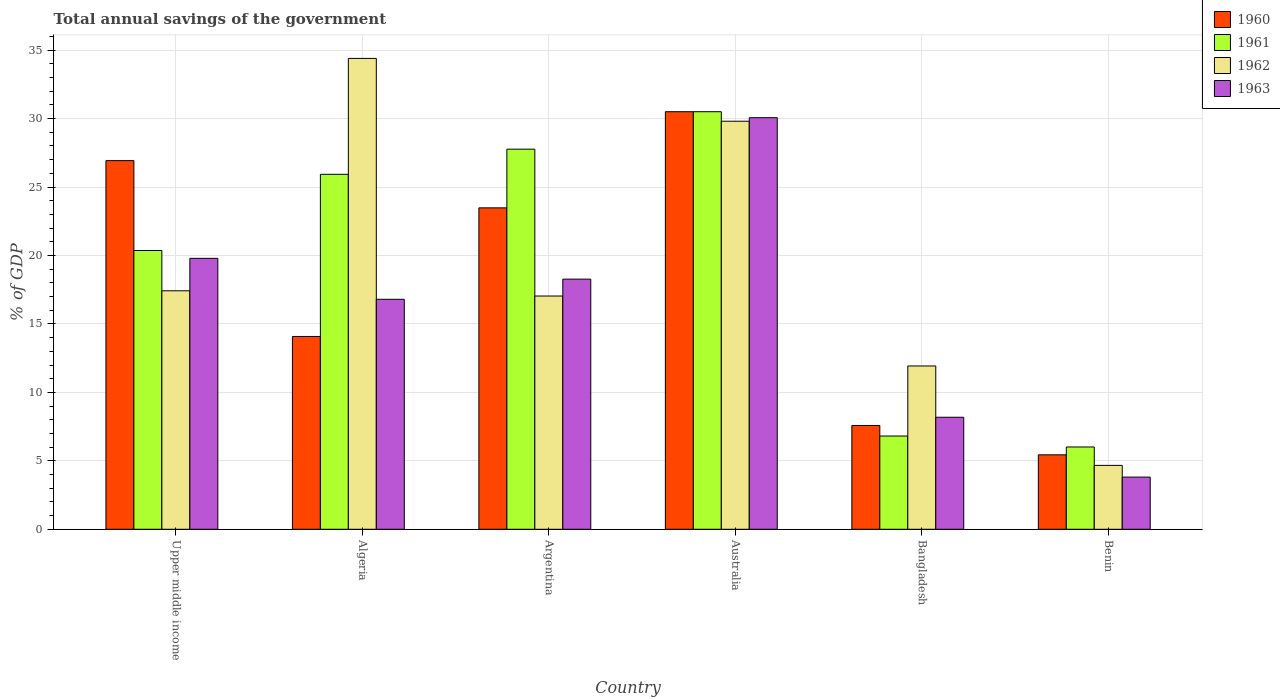How many different coloured bars are there?
Your answer should be compact. 4. Are the number of bars per tick equal to the number of legend labels?
Your answer should be compact. Yes. How many bars are there on the 4th tick from the left?
Give a very brief answer. 4. How many bars are there on the 3rd tick from the right?
Provide a succinct answer. 4. What is the label of the 1st group of bars from the left?
Offer a very short reply. Upper middle income. In how many cases, is the number of bars for a given country not equal to the number of legend labels?
Your response must be concise. 0. What is the total annual savings of the government in 1962 in Upper middle income?
Provide a short and direct response. 17.42. Across all countries, what is the maximum total annual savings of the government in 1960?
Offer a very short reply. 30.5. Across all countries, what is the minimum total annual savings of the government in 1961?
Your answer should be very brief. 6.01. In which country was the total annual savings of the government in 1963 maximum?
Provide a short and direct response. Australia. In which country was the total annual savings of the government in 1962 minimum?
Provide a succinct answer. Benin. What is the total total annual savings of the government in 1963 in the graph?
Provide a succinct answer. 96.92. What is the difference between the total annual savings of the government in 1961 in Argentina and that in Benin?
Offer a terse response. 21.75. What is the difference between the total annual savings of the government in 1961 in Benin and the total annual savings of the government in 1960 in Bangladesh?
Offer a terse response. -1.57. What is the average total annual savings of the government in 1961 per country?
Your response must be concise. 19.56. What is the difference between the total annual savings of the government of/in 1963 and total annual savings of the government of/in 1962 in Benin?
Offer a terse response. -0.86. In how many countries, is the total annual savings of the government in 1963 greater than 9 %?
Make the answer very short. 4. What is the ratio of the total annual savings of the government in 1963 in Benin to that in Upper middle income?
Your answer should be compact. 0.19. Is the total annual savings of the government in 1963 in Argentina less than that in Australia?
Give a very brief answer. Yes. Is the difference between the total annual savings of the government in 1963 in Algeria and Argentina greater than the difference between the total annual savings of the government in 1962 in Algeria and Argentina?
Offer a terse response. No. What is the difference between the highest and the second highest total annual savings of the government in 1960?
Your answer should be compact. -3.57. What is the difference between the highest and the lowest total annual savings of the government in 1963?
Ensure brevity in your answer.  26.25. Is it the case that in every country, the sum of the total annual savings of the government in 1961 and total annual savings of the government in 1960 is greater than the sum of total annual savings of the government in 1963 and total annual savings of the government in 1962?
Provide a short and direct response. No. What does the 4th bar from the right in Argentina represents?
Your answer should be very brief. 1960. How many bars are there?
Your answer should be compact. 24. Are all the bars in the graph horizontal?
Provide a short and direct response. No. How many countries are there in the graph?
Keep it short and to the point. 6. What is the difference between two consecutive major ticks on the Y-axis?
Your response must be concise. 5. How many legend labels are there?
Your answer should be very brief. 4. What is the title of the graph?
Your answer should be compact. Total annual savings of the government. Does "2004" appear as one of the legend labels in the graph?
Your answer should be compact. No. What is the label or title of the Y-axis?
Offer a terse response. % of GDP. What is the % of GDP of 1960 in Upper middle income?
Offer a very short reply. 26.93. What is the % of GDP in 1961 in Upper middle income?
Offer a very short reply. 20.37. What is the % of GDP in 1962 in Upper middle income?
Provide a succinct answer. 17.42. What is the % of GDP in 1963 in Upper middle income?
Your answer should be compact. 19.79. What is the % of GDP in 1960 in Algeria?
Keep it short and to the point. 14.08. What is the % of GDP of 1961 in Algeria?
Your answer should be compact. 25.93. What is the % of GDP of 1962 in Algeria?
Offer a very short reply. 34.4. What is the % of GDP of 1963 in Algeria?
Your response must be concise. 16.8. What is the % of GDP of 1960 in Argentina?
Provide a short and direct response. 23.48. What is the % of GDP of 1961 in Argentina?
Your response must be concise. 27.77. What is the % of GDP in 1962 in Argentina?
Offer a very short reply. 17.04. What is the % of GDP in 1963 in Argentina?
Provide a succinct answer. 18.27. What is the % of GDP of 1960 in Australia?
Offer a very short reply. 30.5. What is the % of GDP of 1961 in Australia?
Your answer should be very brief. 30.5. What is the % of GDP of 1962 in Australia?
Keep it short and to the point. 29.81. What is the % of GDP of 1963 in Australia?
Ensure brevity in your answer.  30.07. What is the % of GDP of 1960 in Bangladesh?
Keep it short and to the point. 7.58. What is the % of GDP of 1961 in Bangladesh?
Make the answer very short. 6.81. What is the % of GDP of 1962 in Bangladesh?
Give a very brief answer. 11.93. What is the % of GDP in 1963 in Bangladesh?
Offer a very short reply. 8.18. What is the % of GDP of 1960 in Benin?
Offer a terse response. 5.44. What is the % of GDP of 1961 in Benin?
Offer a terse response. 6.01. What is the % of GDP of 1962 in Benin?
Offer a terse response. 4.67. What is the % of GDP in 1963 in Benin?
Provide a short and direct response. 3.81. Across all countries, what is the maximum % of GDP in 1960?
Offer a terse response. 30.5. Across all countries, what is the maximum % of GDP of 1961?
Offer a very short reply. 30.5. Across all countries, what is the maximum % of GDP in 1962?
Make the answer very short. 34.4. Across all countries, what is the maximum % of GDP in 1963?
Your answer should be compact. 30.07. Across all countries, what is the minimum % of GDP in 1960?
Provide a short and direct response. 5.44. Across all countries, what is the minimum % of GDP of 1961?
Provide a succinct answer. 6.01. Across all countries, what is the minimum % of GDP in 1962?
Make the answer very short. 4.67. Across all countries, what is the minimum % of GDP of 1963?
Make the answer very short. 3.81. What is the total % of GDP of 1960 in the graph?
Make the answer very short. 108.02. What is the total % of GDP of 1961 in the graph?
Ensure brevity in your answer.  117.39. What is the total % of GDP of 1962 in the graph?
Your response must be concise. 115.26. What is the total % of GDP in 1963 in the graph?
Keep it short and to the point. 96.92. What is the difference between the % of GDP in 1960 in Upper middle income and that in Algeria?
Offer a terse response. 12.84. What is the difference between the % of GDP of 1961 in Upper middle income and that in Algeria?
Give a very brief answer. -5.57. What is the difference between the % of GDP in 1962 in Upper middle income and that in Algeria?
Your answer should be very brief. -16.97. What is the difference between the % of GDP of 1963 in Upper middle income and that in Algeria?
Your answer should be very brief. 2.99. What is the difference between the % of GDP of 1960 in Upper middle income and that in Argentina?
Provide a short and direct response. 3.45. What is the difference between the % of GDP of 1961 in Upper middle income and that in Argentina?
Provide a short and direct response. -7.4. What is the difference between the % of GDP of 1962 in Upper middle income and that in Argentina?
Offer a terse response. 0.38. What is the difference between the % of GDP of 1963 in Upper middle income and that in Argentina?
Your response must be concise. 1.52. What is the difference between the % of GDP in 1960 in Upper middle income and that in Australia?
Provide a succinct answer. -3.57. What is the difference between the % of GDP of 1961 in Upper middle income and that in Australia?
Keep it short and to the point. -10.14. What is the difference between the % of GDP of 1962 in Upper middle income and that in Australia?
Give a very brief answer. -12.39. What is the difference between the % of GDP in 1963 in Upper middle income and that in Australia?
Offer a very short reply. -10.27. What is the difference between the % of GDP of 1960 in Upper middle income and that in Bangladesh?
Make the answer very short. 19.35. What is the difference between the % of GDP of 1961 in Upper middle income and that in Bangladesh?
Your answer should be compact. 13.55. What is the difference between the % of GDP in 1962 in Upper middle income and that in Bangladesh?
Give a very brief answer. 5.49. What is the difference between the % of GDP of 1963 in Upper middle income and that in Bangladesh?
Provide a succinct answer. 11.61. What is the difference between the % of GDP of 1960 in Upper middle income and that in Benin?
Your answer should be very brief. 21.49. What is the difference between the % of GDP in 1961 in Upper middle income and that in Benin?
Offer a very short reply. 14.35. What is the difference between the % of GDP in 1962 in Upper middle income and that in Benin?
Your response must be concise. 12.75. What is the difference between the % of GDP in 1963 in Upper middle income and that in Benin?
Provide a short and direct response. 15.98. What is the difference between the % of GDP of 1960 in Algeria and that in Argentina?
Your response must be concise. -9.4. What is the difference between the % of GDP of 1961 in Algeria and that in Argentina?
Make the answer very short. -1.84. What is the difference between the % of GDP of 1962 in Algeria and that in Argentina?
Your response must be concise. 17.36. What is the difference between the % of GDP of 1963 in Algeria and that in Argentina?
Offer a terse response. -1.47. What is the difference between the % of GDP in 1960 in Algeria and that in Australia?
Your answer should be very brief. -16.42. What is the difference between the % of GDP of 1961 in Algeria and that in Australia?
Your answer should be compact. -4.57. What is the difference between the % of GDP of 1962 in Algeria and that in Australia?
Make the answer very short. 4.59. What is the difference between the % of GDP of 1963 in Algeria and that in Australia?
Keep it short and to the point. -13.27. What is the difference between the % of GDP in 1960 in Algeria and that in Bangladesh?
Make the answer very short. 6.5. What is the difference between the % of GDP in 1961 in Algeria and that in Bangladesh?
Provide a short and direct response. 19.12. What is the difference between the % of GDP in 1962 in Algeria and that in Bangladesh?
Ensure brevity in your answer.  22.47. What is the difference between the % of GDP in 1963 in Algeria and that in Bangladesh?
Keep it short and to the point. 8.62. What is the difference between the % of GDP of 1960 in Algeria and that in Benin?
Offer a very short reply. 8.65. What is the difference between the % of GDP of 1961 in Algeria and that in Benin?
Offer a terse response. 19.92. What is the difference between the % of GDP of 1962 in Algeria and that in Benin?
Make the answer very short. 29.73. What is the difference between the % of GDP in 1963 in Algeria and that in Benin?
Keep it short and to the point. 12.99. What is the difference between the % of GDP of 1960 in Argentina and that in Australia?
Give a very brief answer. -7.02. What is the difference between the % of GDP in 1961 in Argentina and that in Australia?
Your answer should be compact. -2.74. What is the difference between the % of GDP of 1962 in Argentina and that in Australia?
Offer a very short reply. -12.77. What is the difference between the % of GDP of 1963 in Argentina and that in Australia?
Make the answer very short. -11.79. What is the difference between the % of GDP in 1960 in Argentina and that in Bangladesh?
Give a very brief answer. 15.9. What is the difference between the % of GDP in 1961 in Argentina and that in Bangladesh?
Your answer should be very brief. 20.95. What is the difference between the % of GDP of 1962 in Argentina and that in Bangladesh?
Offer a terse response. 5.11. What is the difference between the % of GDP of 1963 in Argentina and that in Bangladesh?
Provide a succinct answer. 10.09. What is the difference between the % of GDP in 1960 in Argentina and that in Benin?
Give a very brief answer. 18.04. What is the difference between the % of GDP of 1961 in Argentina and that in Benin?
Keep it short and to the point. 21.75. What is the difference between the % of GDP of 1962 in Argentina and that in Benin?
Offer a terse response. 12.37. What is the difference between the % of GDP of 1963 in Argentina and that in Benin?
Ensure brevity in your answer.  14.46. What is the difference between the % of GDP in 1960 in Australia and that in Bangladesh?
Make the answer very short. 22.92. What is the difference between the % of GDP of 1961 in Australia and that in Bangladesh?
Keep it short and to the point. 23.69. What is the difference between the % of GDP of 1962 in Australia and that in Bangladesh?
Give a very brief answer. 17.88. What is the difference between the % of GDP in 1963 in Australia and that in Bangladesh?
Your answer should be very brief. 21.88. What is the difference between the % of GDP in 1960 in Australia and that in Benin?
Offer a terse response. 25.06. What is the difference between the % of GDP of 1961 in Australia and that in Benin?
Make the answer very short. 24.49. What is the difference between the % of GDP of 1962 in Australia and that in Benin?
Make the answer very short. 25.14. What is the difference between the % of GDP of 1963 in Australia and that in Benin?
Ensure brevity in your answer.  26.25. What is the difference between the % of GDP of 1960 in Bangladesh and that in Benin?
Offer a very short reply. 2.15. What is the difference between the % of GDP in 1961 in Bangladesh and that in Benin?
Your answer should be very brief. 0.8. What is the difference between the % of GDP of 1962 in Bangladesh and that in Benin?
Make the answer very short. 7.26. What is the difference between the % of GDP of 1963 in Bangladesh and that in Benin?
Keep it short and to the point. 4.37. What is the difference between the % of GDP of 1960 in Upper middle income and the % of GDP of 1962 in Algeria?
Your response must be concise. -7.47. What is the difference between the % of GDP of 1960 in Upper middle income and the % of GDP of 1963 in Algeria?
Ensure brevity in your answer.  10.13. What is the difference between the % of GDP in 1961 in Upper middle income and the % of GDP in 1962 in Algeria?
Offer a terse response. -14.03. What is the difference between the % of GDP in 1961 in Upper middle income and the % of GDP in 1963 in Algeria?
Provide a succinct answer. 3.57. What is the difference between the % of GDP in 1962 in Upper middle income and the % of GDP in 1963 in Algeria?
Offer a very short reply. 0.62. What is the difference between the % of GDP of 1960 in Upper middle income and the % of GDP of 1961 in Argentina?
Your answer should be very brief. -0.84. What is the difference between the % of GDP of 1960 in Upper middle income and the % of GDP of 1962 in Argentina?
Your answer should be compact. 9.89. What is the difference between the % of GDP in 1960 in Upper middle income and the % of GDP in 1963 in Argentina?
Provide a succinct answer. 8.66. What is the difference between the % of GDP in 1961 in Upper middle income and the % of GDP in 1962 in Argentina?
Provide a short and direct response. 3.33. What is the difference between the % of GDP of 1961 in Upper middle income and the % of GDP of 1963 in Argentina?
Your answer should be compact. 2.09. What is the difference between the % of GDP in 1962 in Upper middle income and the % of GDP in 1963 in Argentina?
Provide a short and direct response. -0.85. What is the difference between the % of GDP in 1960 in Upper middle income and the % of GDP in 1961 in Australia?
Give a very brief answer. -3.57. What is the difference between the % of GDP in 1960 in Upper middle income and the % of GDP in 1962 in Australia?
Your answer should be very brief. -2.88. What is the difference between the % of GDP in 1960 in Upper middle income and the % of GDP in 1963 in Australia?
Provide a succinct answer. -3.14. What is the difference between the % of GDP of 1961 in Upper middle income and the % of GDP of 1962 in Australia?
Keep it short and to the point. -9.44. What is the difference between the % of GDP of 1961 in Upper middle income and the % of GDP of 1963 in Australia?
Your answer should be very brief. -9.7. What is the difference between the % of GDP of 1962 in Upper middle income and the % of GDP of 1963 in Australia?
Your answer should be very brief. -12.64. What is the difference between the % of GDP of 1960 in Upper middle income and the % of GDP of 1961 in Bangladesh?
Offer a very short reply. 20.12. What is the difference between the % of GDP of 1960 in Upper middle income and the % of GDP of 1962 in Bangladesh?
Ensure brevity in your answer.  15. What is the difference between the % of GDP of 1960 in Upper middle income and the % of GDP of 1963 in Bangladesh?
Make the answer very short. 18.75. What is the difference between the % of GDP in 1961 in Upper middle income and the % of GDP in 1962 in Bangladesh?
Keep it short and to the point. 8.44. What is the difference between the % of GDP in 1961 in Upper middle income and the % of GDP in 1963 in Bangladesh?
Your answer should be compact. 12.18. What is the difference between the % of GDP of 1962 in Upper middle income and the % of GDP of 1963 in Bangladesh?
Your answer should be very brief. 9.24. What is the difference between the % of GDP of 1960 in Upper middle income and the % of GDP of 1961 in Benin?
Offer a terse response. 20.92. What is the difference between the % of GDP in 1960 in Upper middle income and the % of GDP in 1962 in Benin?
Give a very brief answer. 22.26. What is the difference between the % of GDP of 1960 in Upper middle income and the % of GDP of 1963 in Benin?
Provide a short and direct response. 23.12. What is the difference between the % of GDP of 1961 in Upper middle income and the % of GDP of 1962 in Benin?
Your answer should be very brief. 15.7. What is the difference between the % of GDP in 1961 in Upper middle income and the % of GDP in 1963 in Benin?
Give a very brief answer. 16.55. What is the difference between the % of GDP in 1962 in Upper middle income and the % of GDP in 1963 in Benin?
Offer a terse response. 13.61. What is the difference between the % of GDP of 1960 in Algeria and the % of GDP of 1961 in Argentina?
Offer a very short reply. -13.68. What is the difference between the % of GDP in 1960 in Algeria and the % of GDP in 1962 in Argentina?
Give a very brief answer. -2.96. What is the difference between the % of GDP in 1960 in Algeria and the % of GDP in 1963 in Argentina?
Ensure brevity in your answer.  -4.19. What is the difference between the % of GDP of 1961 in Algeria and the % of GDP of 1962 in Argentina?
Provide a succinct answer. 8.89. What is the difference between the % of GDP in 1961 in Algeria and the % of GDP in 1963 in Argentina?
Your answer should be very brief. 7.66. What is the difference between the % of GDP of 1962 in Algeria and the % of GDP of 1963 in Argentina?
Provide a short and direct response. 16.12. What is the difference between the % of GDP of 1960 in Algeria and the % of GDP of 1961 in Australia?
Provide a short and direct response. -16.42. What is the difference between the % of GDP of 1960 in Algeria and the % of GDP of 1962 in Australia?
Make the answer very short. -15.72. What is the difference between the % of GDP of 1960 in Algeria and the % of GDP of 1963 in Australia?
Your answer should be very brief. -15.98. What is the difference between the % of GDP of 1961 in Algeria and the % of GDP of 1962 in Australia?
Ensure brevity in your answer.  -3.88. What is the difference between the % of GDP in 1961 in Algeria and the % of GDP in 1963 in Australia?
Make the answer very short. -4.13. What is the difference between the % of GDP of 1962 in Algeria and the % of GDP of 1963 in Australia?
Your answer should be compact. 4.33. What is the difference between the % of GDP of 1960 in Algeria and the % of GDP of 1961 in Bangladesh?
Offer a terse response. 7.27. What is the difference between the % of GDP of 1960 in Algeria and the % of GDP of 1962 in Bangladesh?
Your answer should be compact. 2.16. What is the difference between the % of GDP of 1960 in Algeria and the % of GDP of 1963 in Bangladesh?
Keep it short and to the point. 5.9. What is the difference between the % of GDP of 1961 in Algeria and the % of GDP of 1962 in Bangladesh?
Provide a succinct answer. 14. What is the difference between the % of GDP of 1961 in Algeria and the % of GDP of 1963 in Bangladesh?
Your response must be concise. 17.75. What is the difference between the % of GDP of 1962 in Algeria and the % of GDP of 1963 in Bangladesh?
Keep it short and to the point. 26.21. What is the difference between the % of GDP in 1960 in Algeria and the % of GDP in 1961 in Benin?
Give a very brief answer. 8.07. What is the difference between the % of GDP of 1960 in Algeria and the % of GDP of 1962 in Benin?
Make the answer very short. 9.42. What is the difference between the % of GDP in 1960 in Algeria and the % of GDP in 1963 in Benin?
Offer a terse response. 10.27. What is the difference between the % of GDP in 1961 in Algeria and the % of GDP in 1962 in Benin?
Offer a very short reply. 21.26. What is the difference between the % of GDP in 1961 in Algeria and the % of GDP in 1963 in Benin?
Offer a very short reply. 22.12. What is the difference between the % of GDP in 1962 in Algeria and the % of GDP in 1963 in Benin?
Your answer should be compact. 30.58. What is the difference between the % of GDP of 1960 in Argentina and the % of GDP of 1961 in Australia?
Make the answer very short. -7.02. What is the difference between the % of GDP of 1960 in Argentina and the % of GDP of 1962 in Australia?
Offer a very short reply. -6.33. What is the difference between the % of GDP in 1960 in Argentina and the % of GDP in 1963 in Australia?
Keep it short and to the point. -6.59. What is the difference between the % of GDP in 1961 in Argentina and the % of GDP in 1962 in Australia?
Keep it short and to the point. -2.04. What is the difference between the % of GDP of 1961 in Argentina and the % of GDP of 1963 in Australia?
Keep it short and to the point. -2.3. What is the difference between the % of GDP of 1962 in Argentina and the % of GDP of 1963 in Australia?
Offer a very short reply. -13.03. What is the difference between the % of GDP in 1960 in Argentina and the % of GDP in 1961 in Bangladesh?
Your response must be concise. 16.67. What is the difference between the % of GDP of 1960 in Argentina and the % of GDP of 1962 in Bangladesh?
Provide a short and direct response. 11.55. What is the difference between the % of GDP of 1960 in Argentina and the % of GDP of 1963 in Bangladesh?
Offer a very short reply. 15.3. What is the difference between the % of GDP of 1961 in Argentina and the % of GDP of 1962 in Bangladesh?
Make the answer very short. 15.84. What is the difference between the % of GDP of 1961 in Argentina and the % of GDP of 1963 in Bangladesh?
Ensure brevity in your answer.  19.58. What is the difference between the % of GDP in 1962 in Argentina and the % of GDP in 1963 in Bangladesh?
Provide a short and direct response. 8.86. What is the difference between the % of GDP in 1960 in Argentina and the % of GDP in 1961 in Benin?
Make the answer very short. 17.47. What is the difference between the % of GDP in 1960 in Argentina and the % of GDP in 1962 in Benin?
Offer a very short reply. 18.81. What is the difference between the % of GDP of 1960 in Argentina and the % of GDP of 1963 in Benin?
Give a very brief answer. 19.67. What is the difference between the % of GDP in 1961 in Argentina and the % of GDP in 1962 in Benin?
Your response must be concise. 23.1. What is the difference between the % of GDP of 1961 in Argentina and the % of GDP of 1963 in Benin?
Give a very brief answer. 23.95. What is the difference between the % of GDP in 1962 in Argentina and the % of GDP in 1963 in Benin?
Give a very brief answer. 13.23. What is the difference between the % of GDP in 1960 in Australia and the % of GDP in 1961 in Bangladesh?
Offer a very short reply. 23.69. What is the difference between the % of GDP of 1960 in Australia and the % of GDP of 1962 in Bangladesh?
Your answer should be very brief. 18.57. What is the difference between the % of GDP of 1960 in Australia and the % of GDP of 1963 in Bangladesh?
Make the answer very short. 22.32. What is the difference between the % of GDP of 1961 in Australia and the % of GDP of 1962 in Bangladesh?
Keep it short and to the point. 18.57. What is the difference between the % of GDP in 1961 in Australia and the % of GDP in 1963 in Bangladesh?
Keep it short and to the point. 22.32. What is the difference between the % of GDP in 1962 in Australia and the % of GDP in 1963 in Bangladesh?
Your response must be concise. 21.62. What is the difference between the % of GDP in 1960 in Australia and the % of GDP in 1961 in Benin?
Offer a very short reply. 24.49. What is the difference between the % of GDP of 1960 in Australia and the % of GDP of 1962 in Benin?
Keep it short and to the point. 25.83. What is the difference between the % of GDP of 1960 in Australia and the % of GDP of 1963 in Benin?
Your answer should be compact. 26.69. What is the difference between the % of GDP of 1961 in Australia and the % of GDP of 1962 in Benin?
Make the answer very short. 25.84. What is the difference between the % of GDP in 1961 in Australia and the % of GDP in 1963 in Benin?
Provide a succinct answer. 26.69. What is the difference between the % of GDP of 1962 in Australia and the % of GDP of 1963 in Benin?
Ensure brevity in your answer.  26. What is the difference between the % of GDP in 1960 in Bangladesh and the % of GDP in 1961 in Benin?
Your response must be concise. 1.57. What is the difference between the % of GDP in 1960 in Bangladesh and the % of GDP in 1962 in Benin?
Provide a succinct answer. 2.92. What is the difference between the % of GDP in 1960 in Bangladesh and the % of GDP in 1963 in Benin?
Give a very brief answer. 3.77. What is the difference between the % of GDP in 1961 in Bangladesh and the % of GDP in 1962 in Benin?
Keep it short and to the point. 2.14. What is the difference between the % of GDP in 1961 in Bangladesh and the % of GDP in 1963 in Benin?
Your response must be concise. 3. What is the difference between the % of GDP of 1962 in Bangladesh and the % of GDP of 1963 in Benin?
Your answer should be very brief. 8.12. What is the average % of GDP in 1960 per country?
Provide a short and direct response. 18. What is the average % of GDP of 1961 per country?
Your answer should be compact. 19.56. What is the average % of GDP of 1962 per country?
Make the answer very short. 19.21. What is the average % of GDP in 1963 per country?
Give a very brief answer. 16.15. What is the difference between the % of GDP of 1960 and % of GDP of 1961 in Upper middle income?
Your answer should be compact. 6.56. What is the difference between the % of GDP in 1960 and % of GDP in 1962 in Upper middle income?
Your answer should be compact. 9.51. What is the difference between the % of GDP in 1960 and % of GDP in 1963 in Upper middle income?
Keep it short and to the point. 7.14. What is the difference between the % of GDP of 1961 and % of GDP of 1962 in Upper middle income?
Keep it short and to the point. 2.94. What is the difference between the % of GDP in 1961 and % of GDP in 1963 in Upper middle income?
Provide a succinct answer. 0.57. What is the difference between the % of GDP in 1962 and % of GDP in 1963 in Upper middle income?
Your response must be concise. -2.37. What is the difference between the % of GDP in 1960 and % of GDP in 1961 in Algeria?
Offer a very short reply. -11.85. What is the difference between the % of GDP of 1960 and % of GDP of 1962 in Algeria?
Your answer should be very brief. -20.31. What is the difference between the % of GDP in 1960 and % of GDP in 1963 in Algeria?
Your answer should be compact. -2.72. What is the difference between the % of GDP in 1961 and % of GDP in 1962 in Algeria?
Give a very brief answer. -8.47. What is the difference between the % of GDP of 1961 and % of GDP of 1963 in Algeria?
Your answer should be compact. 9.13. What is the difference between the % of GDP in 1962 and % of GDP in 1963 in Algeria?
Make the answer very short. 17.6. What is the difference between the % of GDP of 1960 and % of GDP of 1961 in Argentina?
Your answer should be compact. -4.29. What is the difference between the % of GDP in 1960 and % of GDP in 1962 in Argentina?
Your answer should be compact. 6.44. What is the difference between the % of GDP in 1960 and % of GDP in 1963 in Argentina?
Offer a very short reply. 5.21. What is the difference between the % of GDP of 1961 and % of GDP of 1962 in Argentina?
Give a very brief answer. 10.73. What is the difference between the % of GDP of 1961 and % of GDP of 1963 in Argentina?
Your response must be concise. 9.49. What is the difference between the % of GDP of 1962 and % of GDP of 1963 in Argentina?
Your answer should be compact. -1.23. What is the difference between the % of GDP in 1960 and % of GDP in 1961 in Australia?
Your response must be concise. -0. What is the difference between the % of GDP of 1960 and % of GDP of 1962 in Australia?
Keep it short and to the point. 0.7. What is the difference between the % of GDP of 1960 and % of GDP of 1963 in Australia?
Ensure brevity in your answer.  0.44. What is the difference between the % of GDP in 1961 and % of GDP in 1962 in Australia?
Provide a succinct answer. 0.7. What is the difference between the % of GDP in 1961 and % of GDP in 1963 in Australia?
Your answer should be very brief. 0.44. What is the difference between the % of GDP in 1962 and % of GDP in 1963 in Australia?
Give a very brief answer. -0.26. What is the difference between the % of GDP of 1960 and % of GDP of 1961 in Bangladesh?
Your answer should be compact. 0.77. What is the difference between the % of GDP in 1960 and % of GDP in 1962 in Bangladesh?
Offer a very short reply. -4.35. What is the difference between the % of GDP of 1960 and % of GDP of 1963 in Bangladesh?
Provide a succinct answer. -0.6. What is the difference between the % of GDP of 1961 and % of GDP of 1962 in Bangladesh?
Your answer should be compact. -5.12. What is the difference between the % of GDP in 1961 and % of GDP in 1963 in Bangladesh?
Your answer should be compact. -1.37. What is the difference between the % of GDP of 1962 and % of GDP of 1963 in Bangladesh?
Your answer should be compact. 3.75. What is the difference between the % of GDP in 1960 and % of GDP in 1961 in Benin?
Ensure brevity in your answer.  -0.57. What is the difference between the % of GDP in 1960 and % of GDP in 1962 in Benin?
Give a very brief answer. 0.77. What is the difference between the % of GDP of 1960 and % of GDP of 1963 in Benin?
Your answer should be very brief. 1.63. What is the difference between the % of GDP of 1961 and % of GDP of 1962 in Benin?
Give a very brief answer. 1.34. What is the difference between the % of GDP in 1961 and % of GDP in 1963 in Benin?
Provide a short and direct response. 2.2. What is the difference between the % of GDP in 1962 and % of GDP in 1963 in Benin?
Ensure brevity in your answer.  0.86. What is the ratio of the % of GDP in 1960 in Upper middle income to that in Algeria?
Your answer should be compact. 1.91. What is the ratio of the % of GDP in 1961 in Upper middle income to that in Algeria?
Your answer should be very brief. 0.79. What is the ratio of the % of GDP of 1962 in Upper middle income to that in Algeria?
Offer a very short reply. 0.51. What is the ratio of the % of GDP of 1963 in Upper middle income to that in Algeria?
Your answer should be compact. 1.18. What is the ratio of the % of GDP of 1960 in Upper middle income to that in Argentina?
Your answer should be compact. 1.15. What is the ratio of the % of GDP in 1961 in Upper middle income to that in Argentina?
Your answer should be very brief. 0.73. What is the ratio of the % of GDP of 1962 in Upper middle income to that in Argentina?
Provide a short and direct response. 1.02. What is the ratio of the % of GDP of 1963 in Upper middle income to that in Argentina?
Keep it short and to the point. 1.08. What is the ratio of the % of GDP of 1960 in Upper middle income to that in Australia?
Provide a succinct answer. 0.88. What is the ratio of the % of GDP of 1961 in Upper middle income to that in Australia?
Provide a succinct answer. 0.67. What is the ratio of the % of GDP in 1962 in Upper middle income to that in Australia?
Provide a short and direct response. 0.58. What is the ratio of the % of GDP of 1963 in Upper middle income to that in Australia?
Make the answer very short. 0.66. What is the ratio of the % of GDP of 1960 in Upper middle income to that in Bangladesh?
Provide a succinct answer. 3.55. What is the ratio of the % of GDP of 1961 in Upper middle income to that in Bangladesh?
Offer a terse response. 2.99. What is the ratio of the % of GDP of 1962 in Upper middle income to that in Bangladesh?
Your answer should be very brief. 1.46. What is the ratio of the % of GDP of 1963 in Upper middle income to that in Bangladesh?
Your response must be concise. 2.42. What is the ratio of the % of GDP of 1960 in Upper middle income to that in Benin?
Provide a short and direct response. 4.95. What is the ratio of the % of GDP of 1961 in Upper middle income to that in Benin?
Your response must be concise. 3.39. What is the ratio of the % of GDP in 1962 in Upper middle income to that in Benin?
Make the answer very short. 3.73. What is the ratio of the % of GDP in 1963 in Upper middle income to that in Benin?
Offer a terse response. 5.19. What is the ratio of the % of GDP in 1960 in Algeria to that in Argentina?
Keep it short and to the point. 0.6. What is the ratio of the % of GDP of 1961 in Algeria to that in Argentina?
Ensure brevity in your answer.  0.93. What is the ratio of the % of GDP of 1962 in Algeria to that in Argentina?
Your response must be concise. 2.02. What is the ratio of the % of GDP in 1963 in Algeria to that in Argentina?
Your answer should be compact. 0.92. What is the ratio of the % of GDP in 1960 in Algeria to that in Australia?
Offer a terse response. 0.46. What is the ratio of the % of GDP of 1961 in Algeria to that in Australia?
Make the answer very short. 0.85. What is the ratio of the % of GDP in 1962 in Algeria to that in Australia?
Make the answer very short. 1.15. What is the ratio of the % of GDP in 1963 in Algeria to that in Australia?
Keep it short and to the point. 0.56. What is the ratio of the % of GDP in 1960 in Algeria to that in Bangladesh?
Provide a short and direct response. 1.86. What is the ratio of the % of GDP of 1961 in Algeria to that in Bangladesh?
Ensure brevity in your answer.  3.81. What is the ratio of the % of GDP in 1962 in Algeria to that in Bangladesh?
Ensure brevity in your answer.  2.88. What is the ratio of the % of GDP of 1963 in Algeria to that in Bangladesh?
Your response must be concise. 2.05. What is the ratio of the % of GDP in 1960 in Algeria to that in Benin?
Ensure brevity in your answer.  2.59. What is the ratio of the % of GDP in 1961 in Algeria to that in Benin?
Your answer should be compact. 4.31. What is the ratio of the % of GDP of 1962 in Algeria to that in Benin?
Offer a very short reply. 7.37. What is the ratio of the % of GDP in 1963 in Algeria to that in Benin?
Your answer should be very brief. 4.41. What is the ratio of the % of GDP in 1960 in Argentina to that in Australia?
Provide a succinct answer. 0.77. What is the ratio of the % of GDP of 1961 in Argentina to that in Australia?
Provide a succinct answer. 0.91. What is the ratio of the % of GDP of 1962 in Argentina to that in Australia?
Offer a terse response. 0.57. What is the ratio of the % of GDP of 1963 in Argentina to that in Australia?
Your answer should be compact. 0.61. What is the ratio of the % of GDP of 1960 in Argentina to that in Bangladesh?
Keep it short and to the point. 3.1. What is the ratio of the % of GDP in 1961 in Argentina to that in Bangladesh?
Make the answer very short. 4.08. What is the ratio of the % of GDP in 1962 in Argentina to that in Bangladesh?
Offer a very short reply. 1.43. What is the ratio of the % of GDP in 1963 in Argentina to that in Bangladesh?
Offer a very short reply. 2.23. What is the ratio of the % of GDP of 1960 in Argentina to that in Benin?
Your response must be concise. 4.32. What is the ratio of the % of GDP of 1961 in Argentina to that in Benin?
Offer a very short reply. 4.62. What is the ratio of the % of GDP of 1962 in Argentina to that in Benin?
Your answer should be very brief. 3.65. What is the ratio of the % of GDP of 1963 in Argentina to that in Benin?
Provide a short and direct response. 4.79. What is the ratio of the % of GDP in 1960 in Australia to that in Bangladesh?
Provide a short and direct response. 4.02. What is the ratio of the % of GDP in 1961 in Australia to that in Bangladesh?
Your response must be concise. 4.48. What is the ratio of the % of GDP in 1962 in Australia to that in Bangladesh?
Make the answer very short. 2.5. What is the ratio of the % of GDP of 1963 in Australia to that in Bangladesh?
Your answer should be compact. 3.67. What is the ratio of the % of GDP in 1960 in Australia to that in Benin?
Offer a terse response. 5.61. What is the ratio of the % of GDP of 1961 in Australia to that in Benin?
Give a very brief answer. 5.07. What is the ratio of the % of GDP of 1962 in Australia to that in Benin?
Your answer should be very brief. 6.39. What is the ratio of the % of GDP in 1963 in Australia to that in Benin?
Your answer should be very brief. 7.89. What is the ratio of the % of GDP of 1960 in Bangladesh to that in Benin?
Provide a short and direct response. 1.39. What is the ratio of the % of GDP of 1961 in Bangladesh to that in Benin?
Offer a terse response. 1.13. What is the ratio of the % of GDP in 1962 in Bangladesh to that in Benin?
Offer a very short reply. 2.56. What is the ratio of the % of GDP in 1963 in Bangladesh to that in Benin?
Your answer should be compact. 2.15. What is the difference between the highest and the second highest % of GDP in 1960?
Offer a terse response. 3.57. What is the difference between the highest and the second highest % of GDP of 1961?
Make the answer very short. 2.74. What is the difference between the highest and the second highest % of GDP of 1962?
Provide a succinct answer. 4.59. What is the difference between the highest and the second highest % of GDP of 1963?
Provide a short and direct response. 10.27. What is the difference between the highest and the lowest % of GDP of 1960?
Offer a very short reply. 25.06. What is the difference between the highest and the lowest % of GDP in 1961?
Your response must be concise. 24.49. What is the difference between the highest and the lowest % of GDP in 1962?
Offer a terse response. 29.73. What is the difference between the highest and the lowest % of GDP of 1963?
Provide a short and direct response. 26.25. 